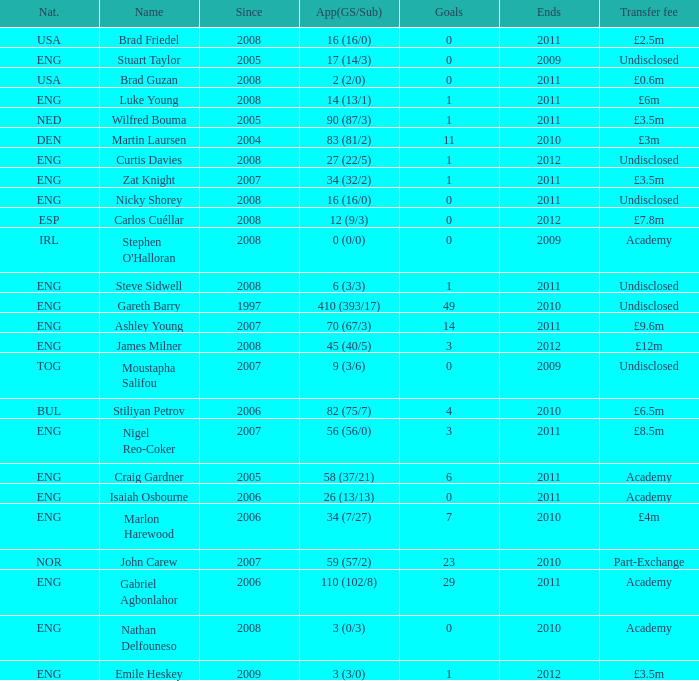What is the total amount when the transfer fee is £8.5 million? 2011.0. 